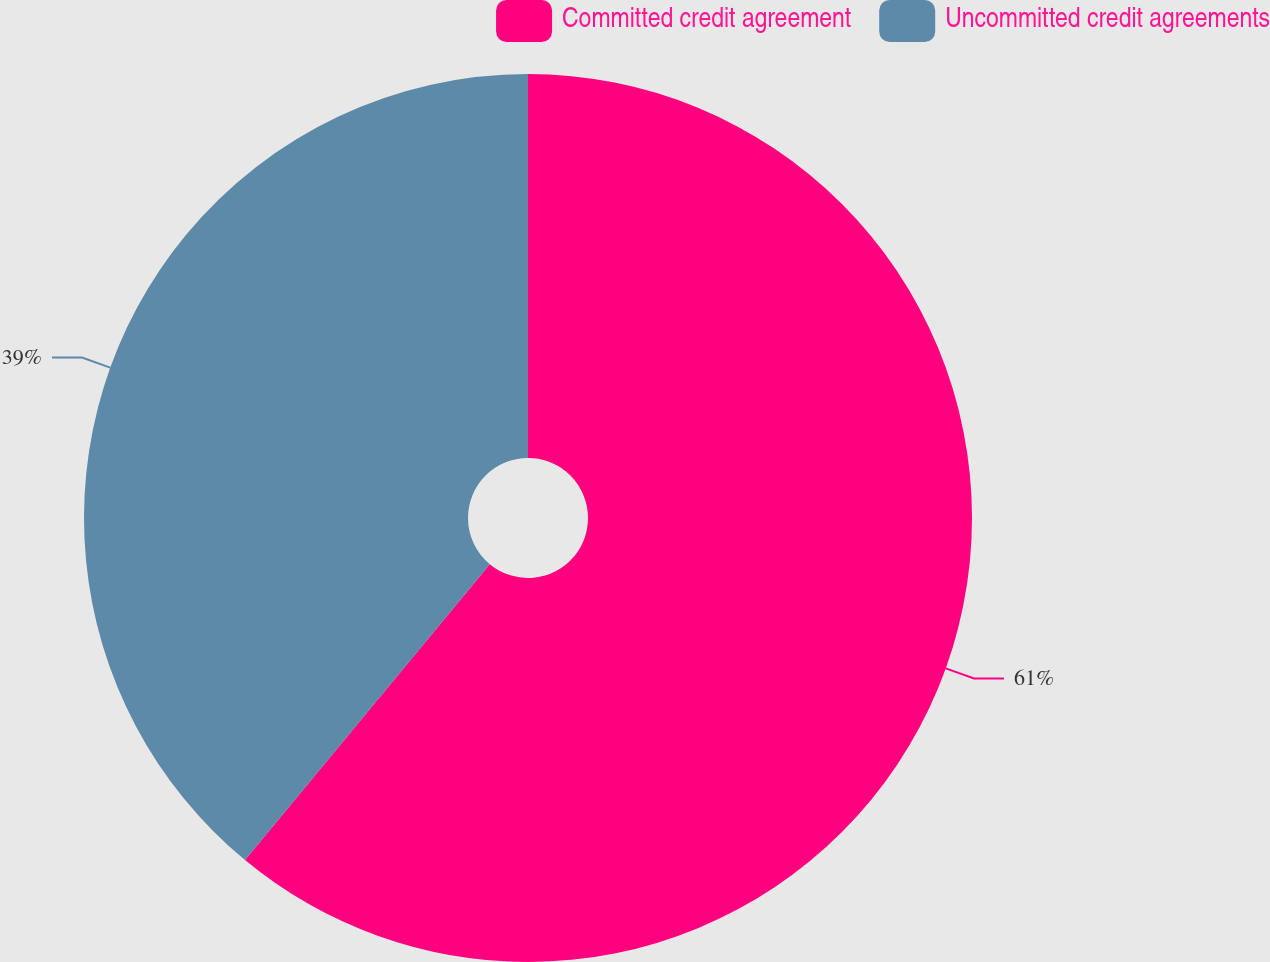Convert chart. <chart><loc_0><loc_0><loc_500><loc_500><pie_chart><fcel>Committed credit agreement<fcel>Uncommitted credit agreements<nl><fcel>61.0%<fcel>39.0%<nl></chart> 